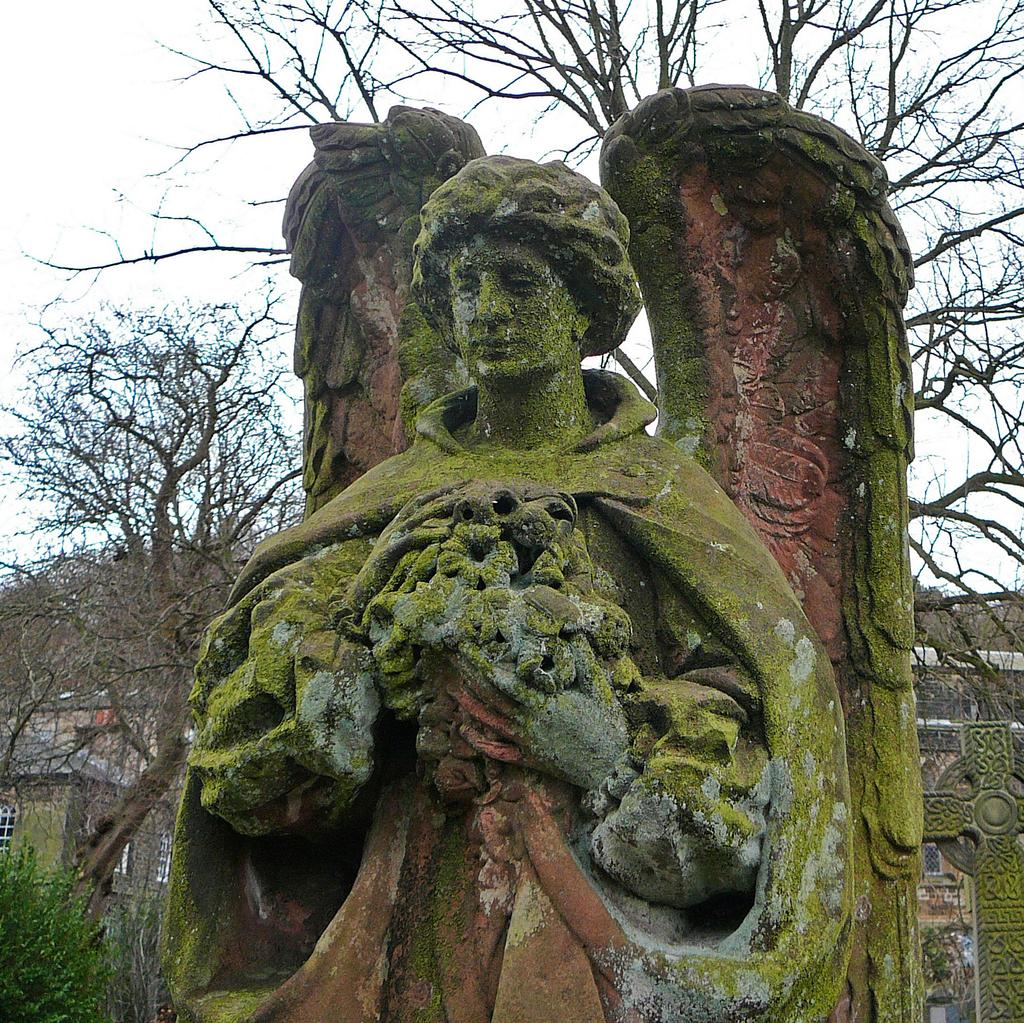What is the main subject in the middle of the image? There is a statue in the middle of the image. What is the color of the statue? The statue is green in color. What can be seen in the background of the image? There are trees and buildings in the background of the image. What is visible at the top of the image? The sky is visible at the top of the image. What type of wire is used to hold the furniture in the image? There is no wire or furniture present in the image; it features a green statue with a background of trees and buildings. 